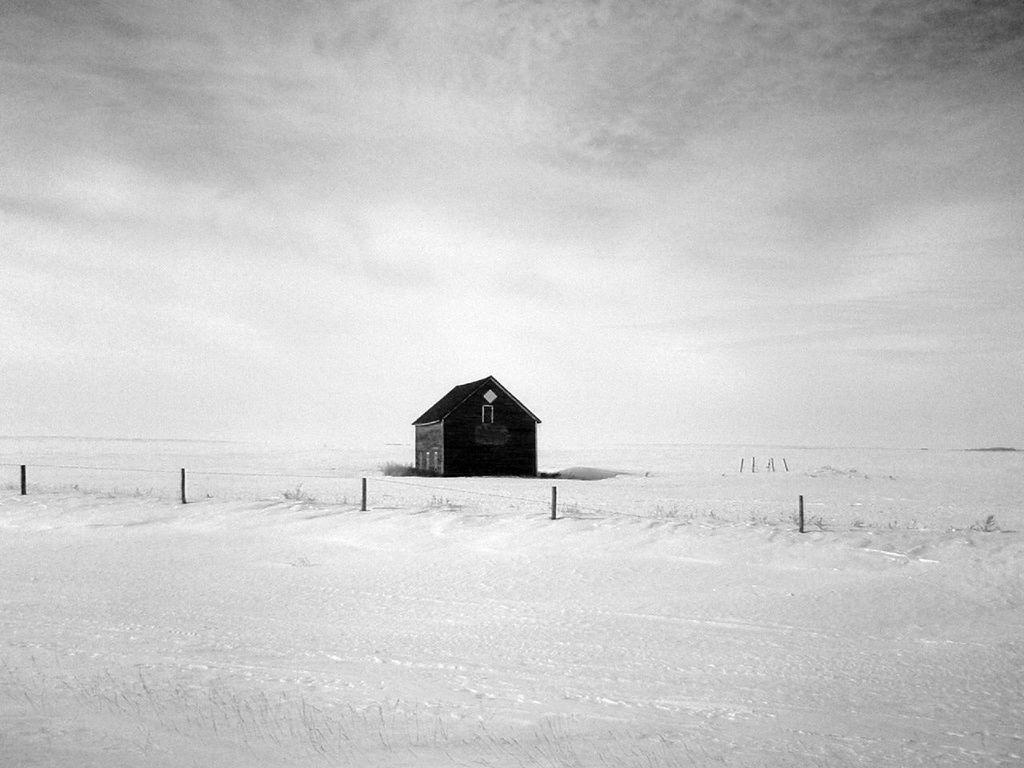What type of area is depicted in the image? There is an open ground in the image. What structures can be seen on the open ground? There are poles and a shack on the open ground. What is the color scheme of the image? The image is black and white in color. What type of fly can be heard in the image? There is no fly or sound present in the image, as it is a black and white photograph. 